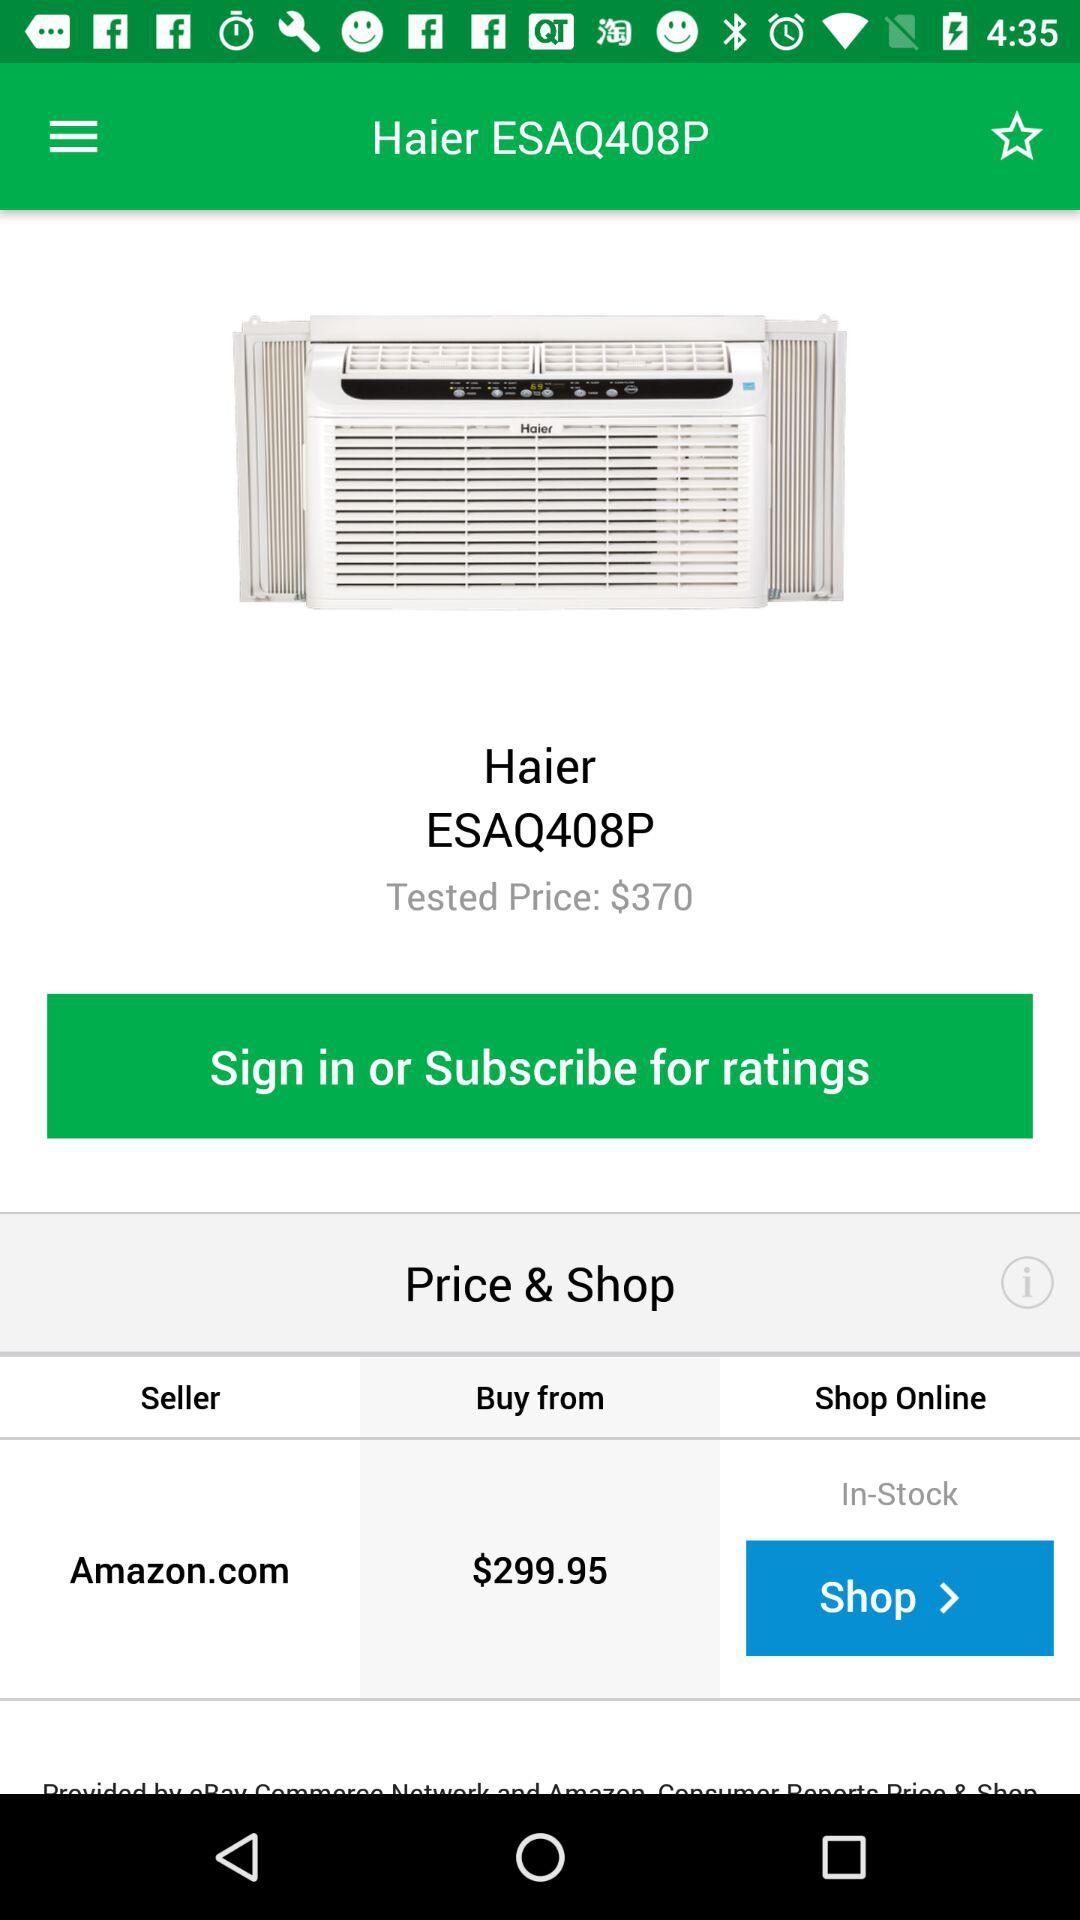What is the tested price? The tested price is $370. 